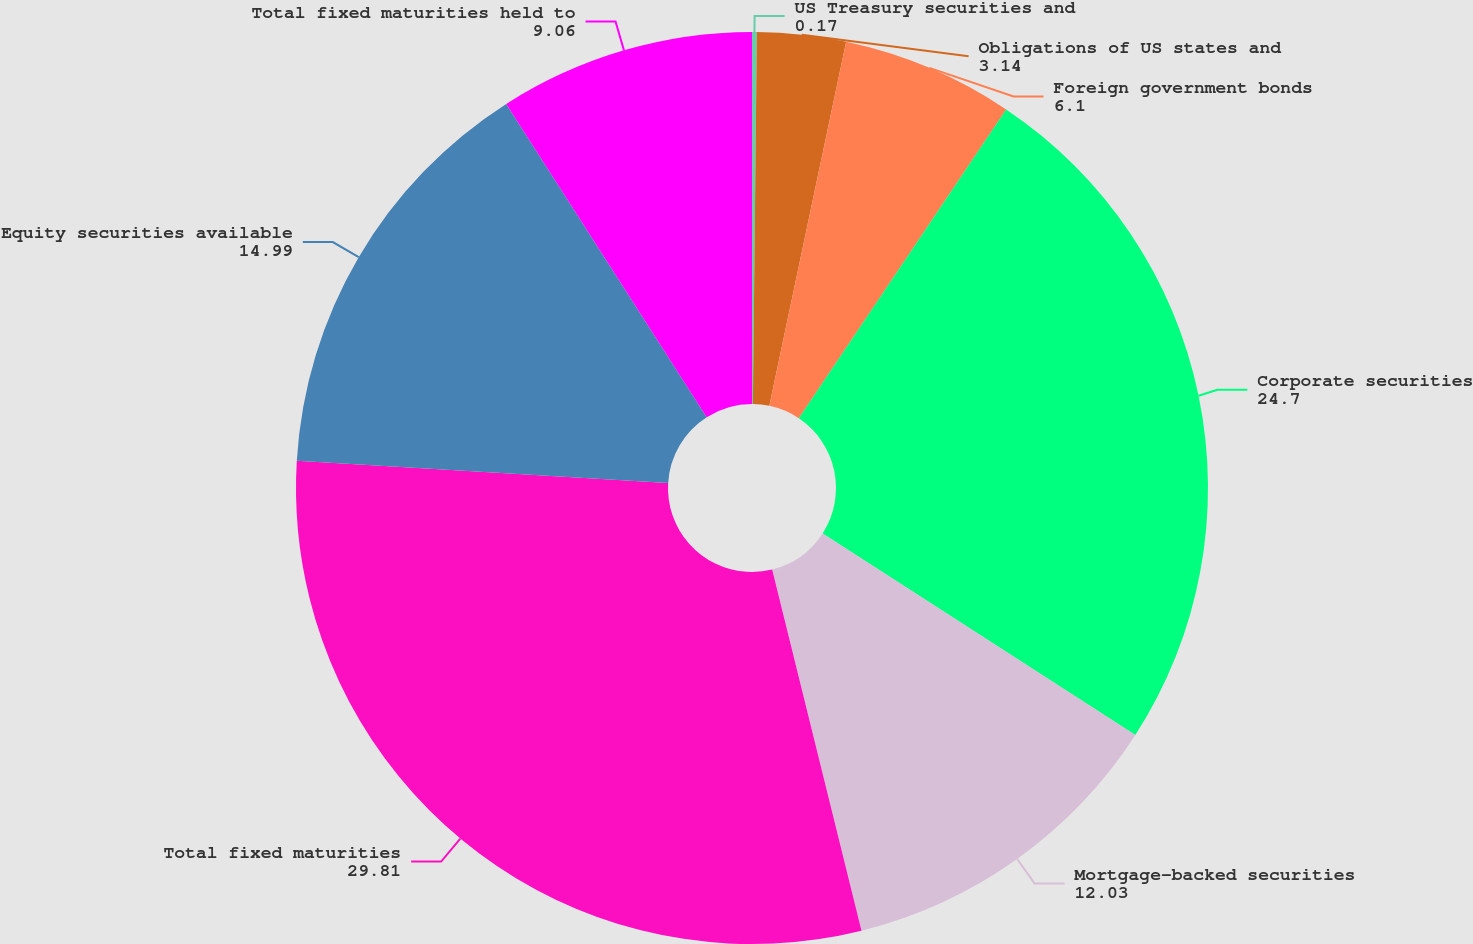Convert chart to OTSL. <chart><loc_0><loc_0><loc_500><loc_500><pie_chart><fcel>US Treasury securities and<fcel>Obligations of US states and<fcel>Foreign government bonds<fcel>Corporate securities<fcel>Mortgage-backed securities<fcel>Total fixed maturities<fcel>Equity securities available<fcel>Total fixed maturities held to<nl><fcel>0.17%<fcel>3.14%<fcel>6.1%<fcel>24.7%<fcel>12.03%<fcel>29.81%<fcel>14.99%<fcel>9.06%<nl></chart> 